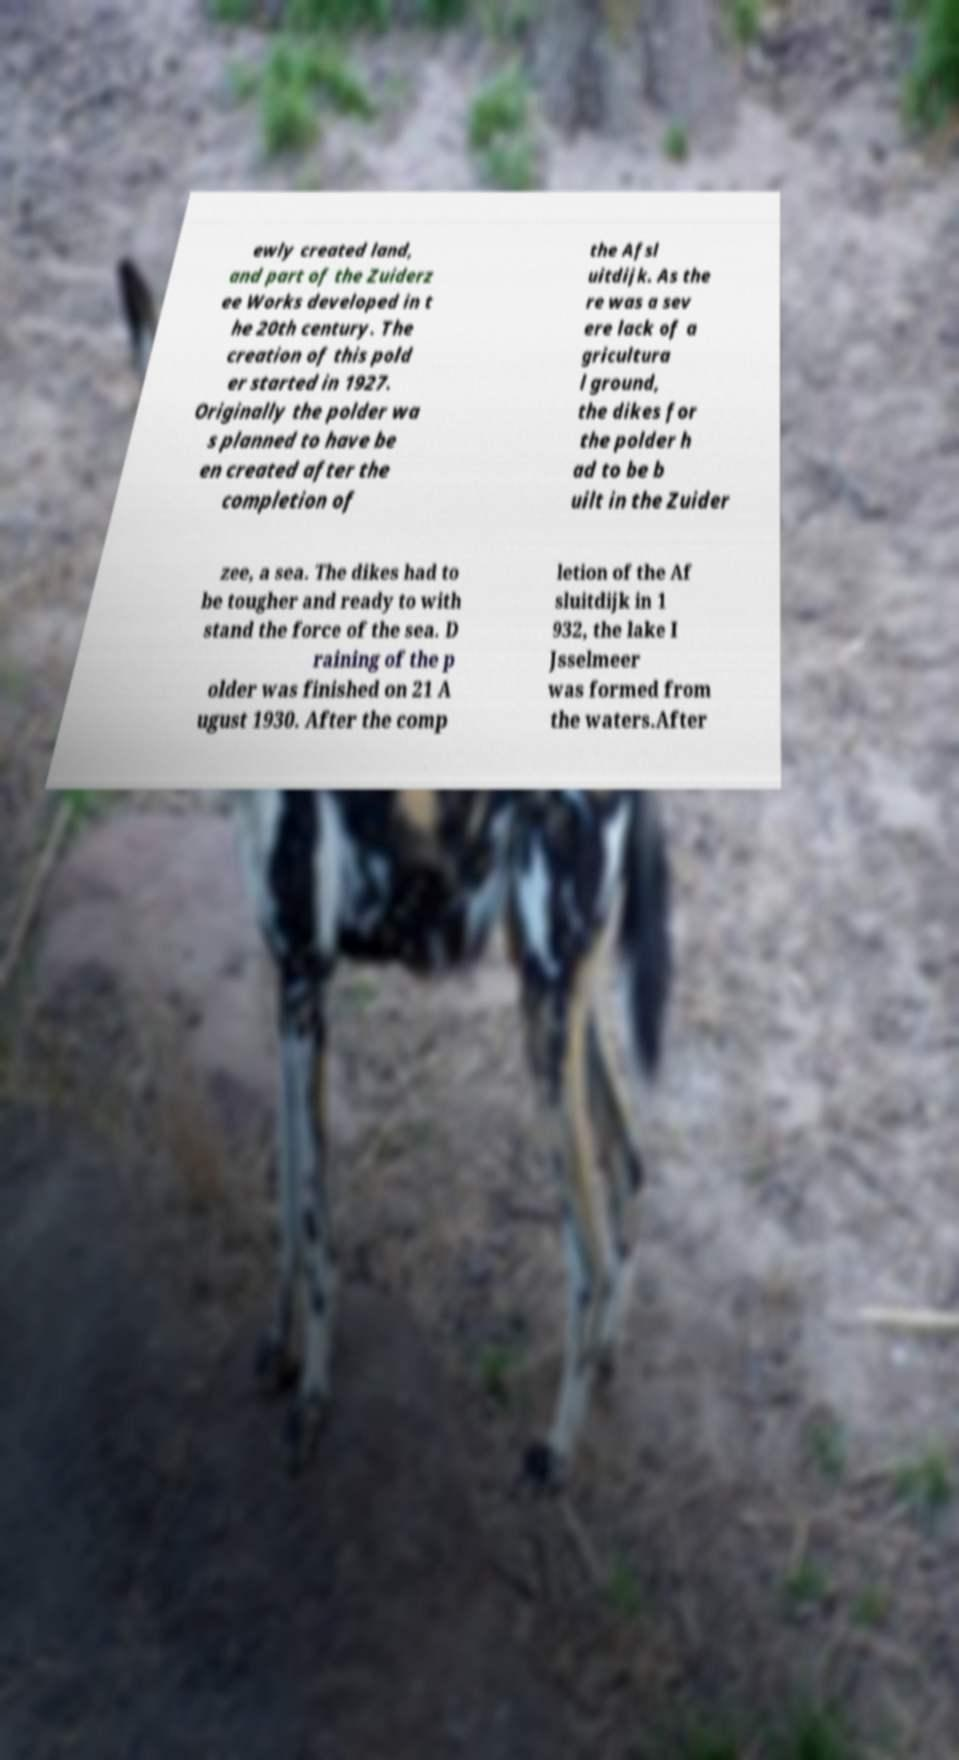What messages or text are displayed in this image? I need them in a readable, typed format. ewly created land, and part of the Zuiderz ee Works developed in t he 20th century. The creation of this pold er started in 1927. Originally the polder wa s planned to have be en created after the completion of the Afsl uitdijk. As the re was a sev ere lack of a gricultura l ground, the dikes for the polder h ad to be b uilt in the Zuider zee, a sea. The dikes had to be tougher and ready to with stand the force of the sea. D raining of the p older was finished on 21 A ugust 1930. After the comp letion of the Af sluitdijk in 1 932, the lake I Jsselmeer was formed from the waters.After 